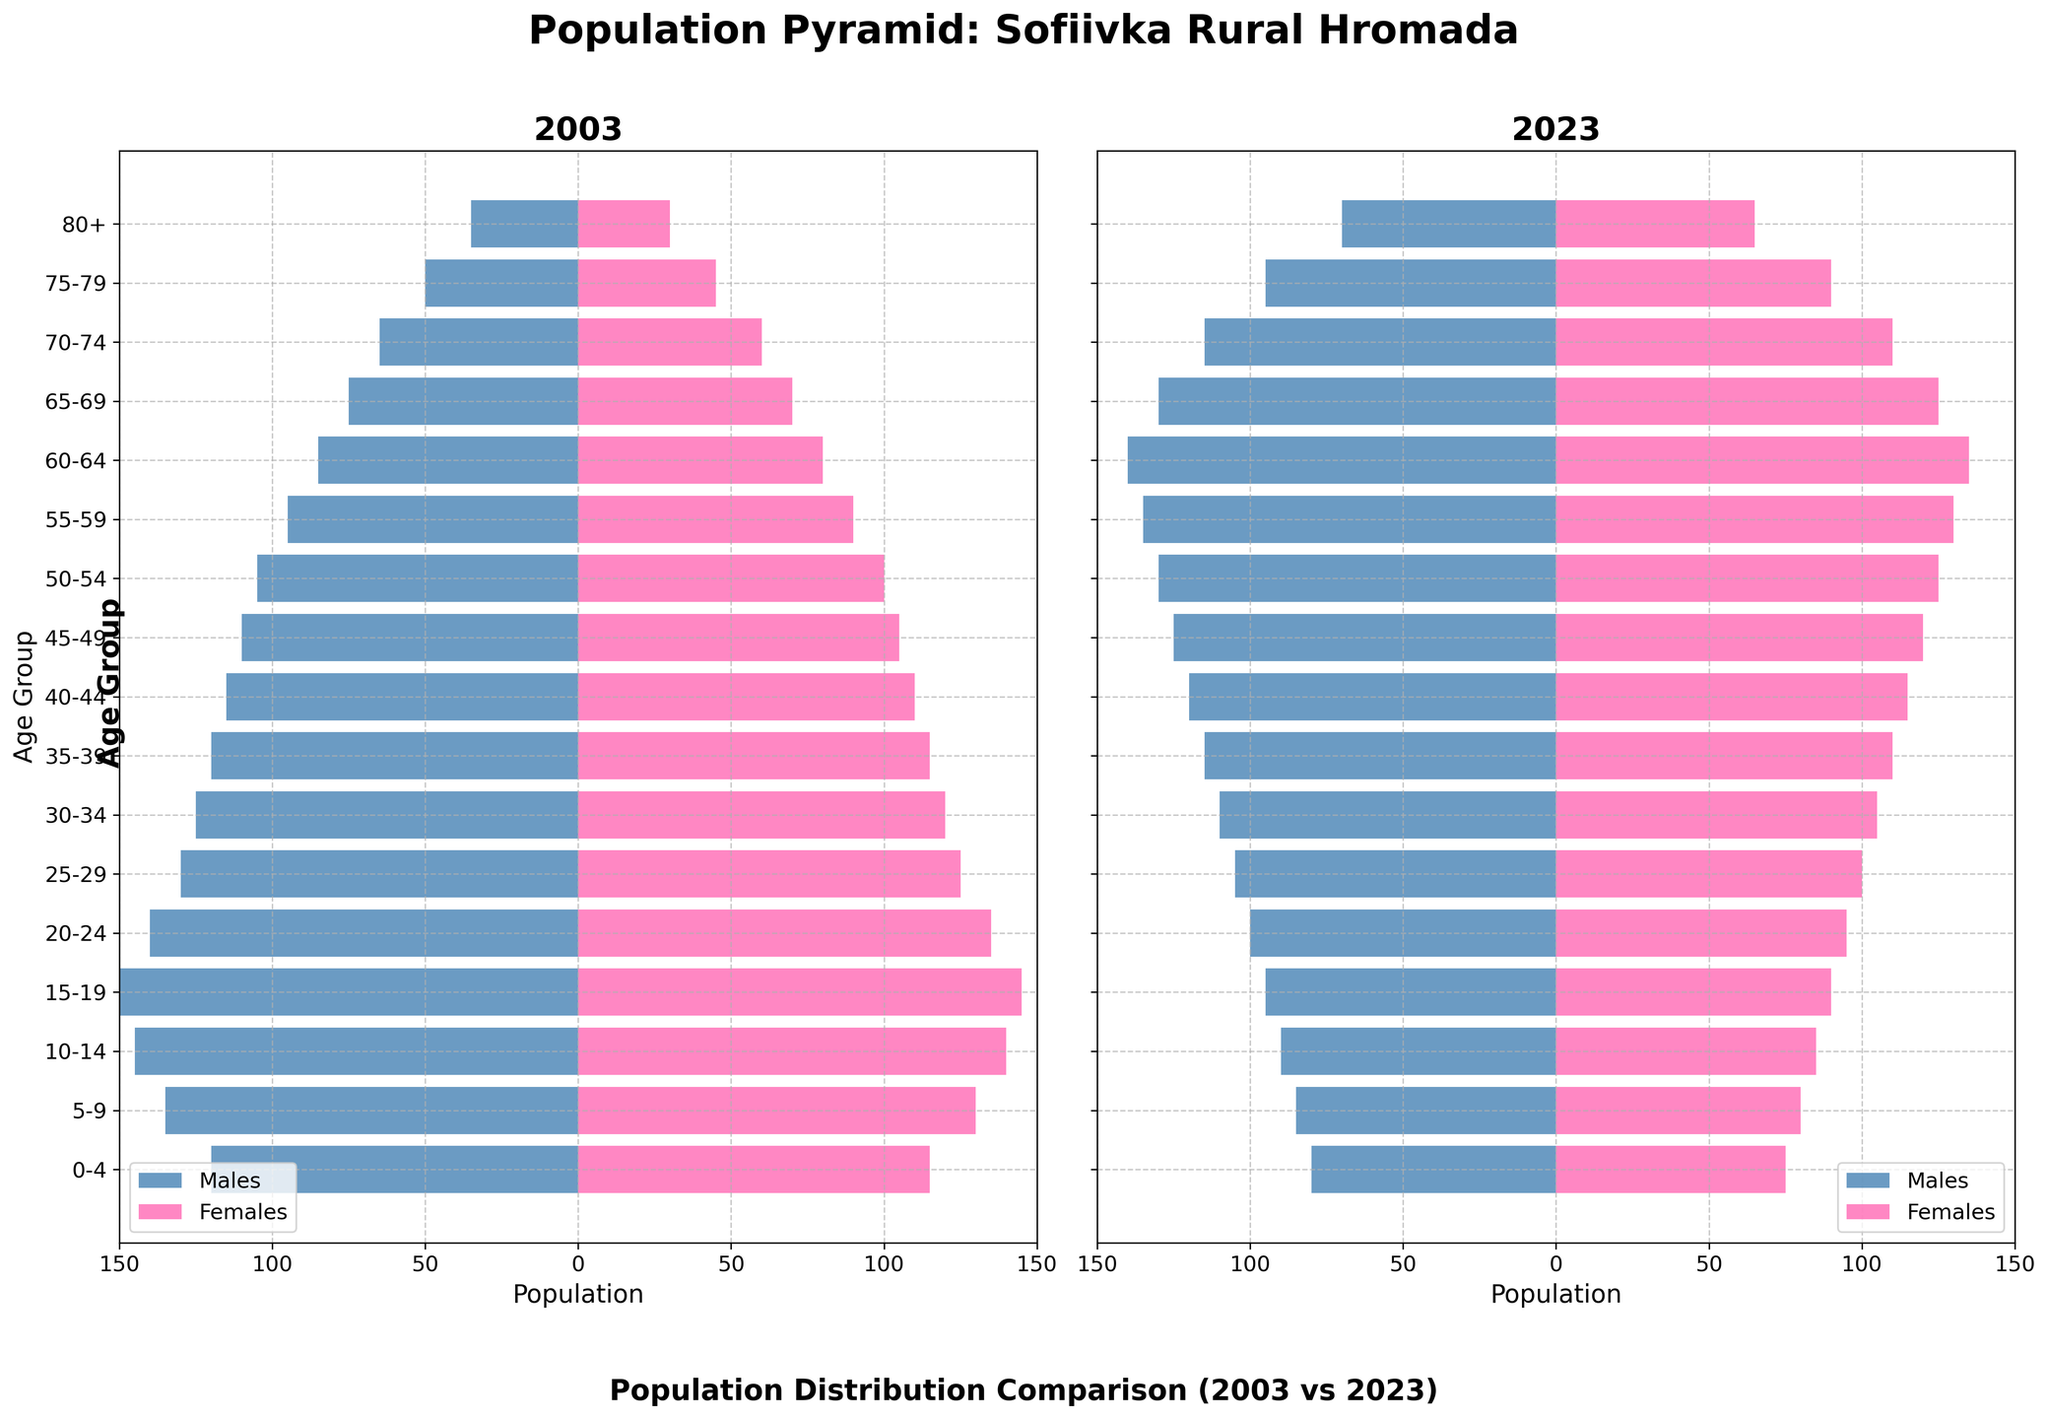How many age groups are presented in the population pyramid? The figure shows between the ages 0 to 80+, revealing 18 age groups in total.
Answer: 18 What is the population of males in the 0-4 age group in 2023? The bars indicate the population of males for each age group. For the 0-4 age group in 2023, it reaches 80.
Answer: 80 Which age group had the largest male population in 2003? By comparing the lengths of the bars for males in 2003, the 10-14 age group had the largest male population, corresponding to a value of 145.
Answer: 10-14 In which year, 2003 or 2023, did the 70-74 age group have a higher female population? Observing the bars for females in the 70-74 age group, the value is larger in 2023 with a value of 110 compared to 60 in 2003.
Answer: 2023 What is the difference in the male population of the 60-64 age group between 2003 and 2023? The male population in 2003 for the 60-64 age group is 85, and in 2023 it's 140. The difference is 140 - 85 = 55.
Answer: 55 Has the population of females aged 80+ increased or decreased from 2003 to 2023? From looking at the bars for females in the 80+ age group, the population has increased from 30 in 2003 to 65 in 2023.
Answer: Increased What trends can be observed about the changes in male and female population for the age groups 0-24 from 2003 to 2023? By comparing the bar lengths, both male and female populations in age groups 0-24 have decreased over the 20 years.
Answer: Decreased Which year had a higher overall population for the age group 55-59, and what is the combined population for both genders for that year? The 55-59 age group in 2023 has males (135) and females (130), totaling 265. In 2003, it's males (95) and females (90), totaling 185. 2023 had the higher combined population.
Answer: 2023, 265 In the 25-29 age group, which gender had a larger decrease in population from 2003 to 2023? For the 25-29 age group, males decreased from 130 to 105 (a decrease of 25), and females decreased from 125 to 100 (a decrease of 25). There is no difference so the decrease is equal for both genders.
Answer: Equal 